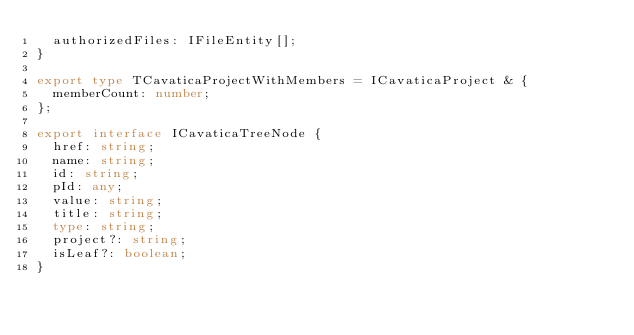<code> <loc_0><loc_0><loc_500><loc_500><_TypeScript_>  authorizedFiles: IFileEntity[];
}

export type TCavaticaProjectWithMembers = ICavaticaProject & {
  memberCount: number;
};

export interface ICavaticaTreeNode {
  href: string;
  name: string;
  id: string;
  pId: any;
  value: string;
  title: string;
  type: string;
  project?: string;
  isLeaf?: boolean;
}
</code> 